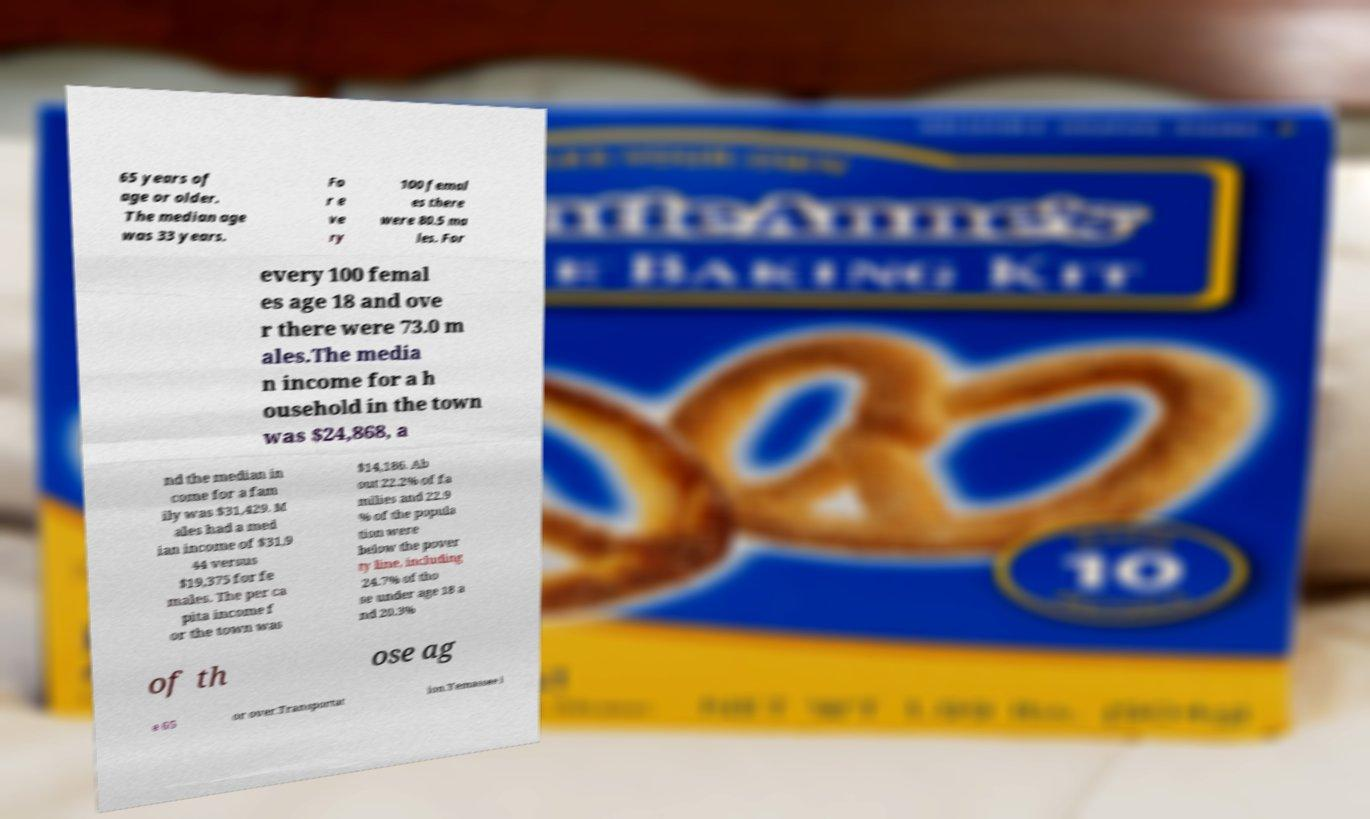Can you read and provide the text displayed in the image?This photo seems to have some interesting text. Can you extract and type it out for me? 65 years of age or older. The median age was 33 years. Fo r e ve ry 100 femal es there were 80.5 ma les. For every 100 femal es age 18 and ove r there were 73.0 m ales.The media n income for a h ousehold in the town was $24,868, a nd the median in come for a fam ily was $31,429. M ales had a med ian income of $31,9 44 versus $19,375 for fe males. The per ca pita income f or the town was $14,186. Ab out 22.2% of fa milies and 22.9 % of the popula tion were below the pover ty line, including 24.7% of tho se under age 18 a nd 20.3% of th ose ag e 65 or over.Transportat ion.Yemassee i 